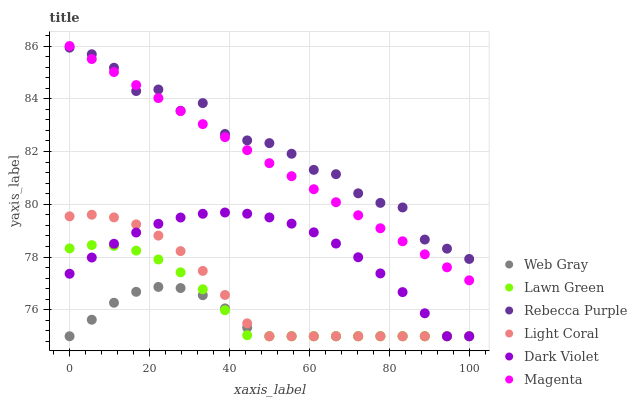Does Web Gray have the minimum area under the curve?
Answer yes or no. Yes. Does Rebecca Purple have the maximum area under the curve?
Answer yes or no. Yes. Does Dark Violet have the minimum area under the curve?
Answer yes or no. No. Does Dark Violet have the maximum area under the curve?
Answer yes or no. No. Is Magenta the smoothest?
Answer yes or no. Yes. Is Rebecca Purple the roughest?
Answer yes or no. Yes. Is Web Gray the smoothest?
Answer yes or no. No. Is Web Gray the roughest?
Answer yes or no. No. Does Lawn Green have the lowest value?
Answer yes or no. Yes. Does Rebecca Purple have the lowest value?
Answer yes or no. No. Does Magenta have the highest value?
Answer yes or no. Yes. Does Dark Violet have the highest value?
Answer yes or no. No. Is Lawn Green less than Rebecca Purple?
Answer yes or no. Yes. Is Rebecca Purple greater than Lawn Green?
Answer yes or no. Yes. Does Lawn Green intersect Light Coral?
Answer yes or no. Yes. Is Lawn Green less than Light Coral?
Answer yes or no. No. Is Lawn Green greater than Light Coral?
Answer yes or no. No. Does Lawn Green intersect Rebecca Purple?
Answer yes or no. No. 